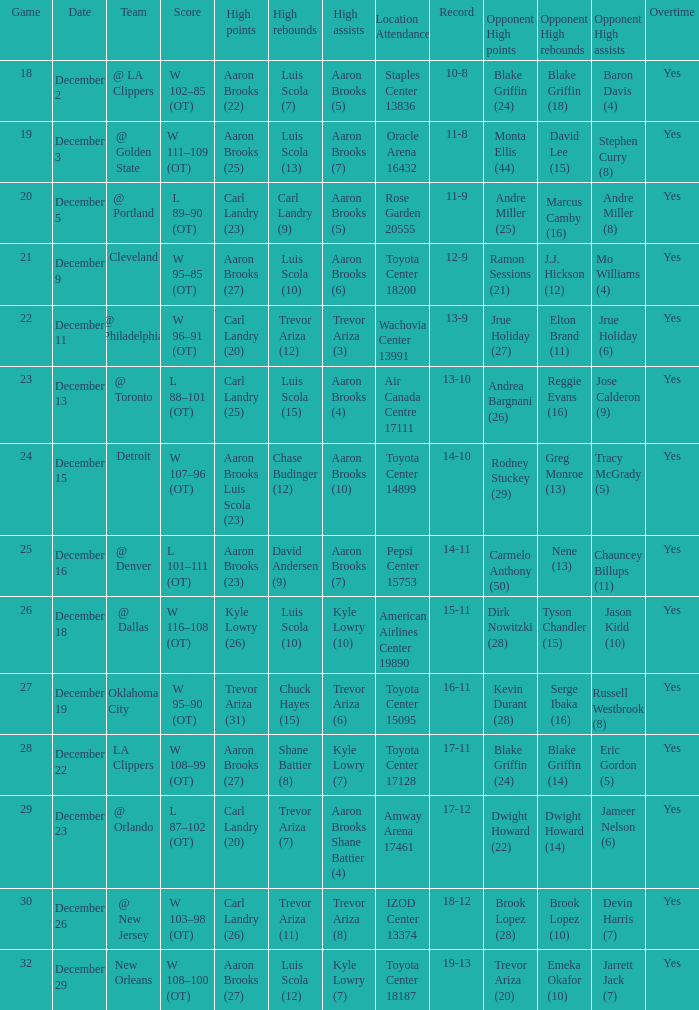Who did the high rebounds in the game where Carl Landry (23) did the most high points? Carl Landry (9). Write the full table. {'header': ['Game', 'Date', 'Team', 'Score', 'High points', 'High rebounds', 'High assists', 'Location Attendance', 'Record', 'Opponent High points', 'Opponent High rebounds', 'Opponent High assists', 'Overtime'], 'rows': [['18', 'December 2', '@ LA Clippers', 'W 102–85 (OT)', 'Aaron Brooks (22)', 'Luis Scola (7)', 'Aaron Brooks (5)', 'Staples Center 13836', '10-8', 'Blake Griffin (24)', 'Blake Griffin (18)', 'Baron Davis (4)', 'Yes'], ['19', 'December 3', '@ Golden State', 'W 111–109 (OT)', 'Aaron Brooks (25)', 'Luis Scola (13)', 'Aaron Brooks (7)', 'Oracle Arena 16432', '11-8', 'Monta Ellis (44)', 'David Lee (15)', 'Stephen Curry (8)', 'Yes'], ['20', 'December 5', '@ Portland', 'L 89–90 (OT)', 'Carl Landry (23)', 'Carl Landry (9)', 'Aaron Brooks (5)', 'Rose Garden 20555', '11-9', 'Andre Miller (25)', 'Marcus Camby (16)', 'Andre Miller (8)', 'Yes'], ['21', 'December 9', 'Cleveland', 'W 95–85 (OT)', 'Aaron Brooks (27)', 'Luis Scola (10)', 'Aaron Brooks (6)', 'Toyota Center 18200', '12-9', 'Ramon Sessions (21)', 'J.J. Hickson (12)', 'Mo Williams (4)', 'Yes'], ['22', 'December 11', '@ Philadelphia', 'W 96–91 (OT)', 'Carl Landry (20)', 'Trevor Ariza (12)', 'Trevor Ariza (3)', 'Wachovia Center 13991', '13-9', 'Jrue Holiday (27)', 'Elton Brand (11)', 'Jrue Holiday (6)', 'Yes'], ['23', 'December 13', '@ Toronto', 'L 88–101 (OT)', 'Carl Landry (25)', 'Luis Scola (15)', 'Aaron Brooks (4)', 'Air Canada Centre 17111', '13-10', 'Andrea Bargnani (26)', 'Reggie Evans (16)', 'Jose Calderon (9)', 'Yes'], ['24', 'December 15', 'Detroit', 'W 107–96 (OT)', 'Aaron Brooks Luis Scola (23)', 'Chase Budinger (12)', 'Aaron Brooks (10)', 'Toyota Center 14899', '14-10', 'Rodney Stuckey (29)', 'Greg Monroe (13)', 'Tracy McGrady (5)', 'Yes'], ['25', 'December 16', '@ Denver', 'L 101–111 (OT)', 'Aaron Brooks (23)', 'David Andersen (9)', 'Aaron Brooks (7)', 'Pepsi Center 15753', '14-11', 'Carmelo Anthony (50)', 'Nene (13)', 'Chauncey Billups (11)', 'Yes'], ['26', 'December 18', '@ Dallas', 'W 116–108 (OT)', 'Kyle Lowry (26)', 'Luis Scola (10)', 'Kyle Lowry (10)', 'American Airlines Center 19890', '15-11', 'Dirk Nowitzki (28)', 'Tyson Chandler (15)', 'Jason Kidd (10)', 'Yes'], ['27', 'December 19', 'Oklahoma City', 'W 95–90 (OT)', 'Trevor Ariza (31)', 'Chuck Hayes (15)', 'Trevor Ariza (6)', 'Toyota Center 15095', '16-11', 'Kevin Durant (28)', 'Serge Ibaka (16)', 'Russell Westbrook (8)', 'Yes'], ['28', 'December 22', 'LA Clippers', 'W 108–99 (OT)', 'Aaron Brooks (27)', 'Shane Battier (8)', 'Kyle Lowry (7)', 'Toyota Center 17128', '17-11', 'Blake Griffin (24)', 'Blake Griffin (14)', 'Eric Gordon (5)', 'Yes'], ['29', 'December 23', '@ Orlando', 'L 87–102 (OT)', 'Carl Landry (20)', 'Trevor Ariza (7)', 'Aaron Brooks Shane Battier (4)', 'Amway Arena 17461', '17-12', 'Dwight Howard (22)', 'Dwight Howard (14)', 'Jameer Nelson (6)', 'Yes'], ['30', 'December 26', '@ New Jersey', 'W 103–98 (OT)', 'Carl Landry (26)', 'Trevor Ariza (11)', 'Trevor Ariza (8)', 'IZOD Center 13374', '18-12', 'Brook Lopez (28)', 'Brook Lopez (10)', 'Devin Harris (7)', 'Yes'], ['32', 'December 29', 'New Orleans', 'W 108–100 (OT)', 'Aaron Brooks (27)', 'Luis Scola (12)', 'Kyle Lowry (7)', 'Toyota Center 18187', '19-13', 'Trevor Ariza (20)', 'Emeka Okafor (10)', 'Jarrett Jack (7)', 'Yes']]} 